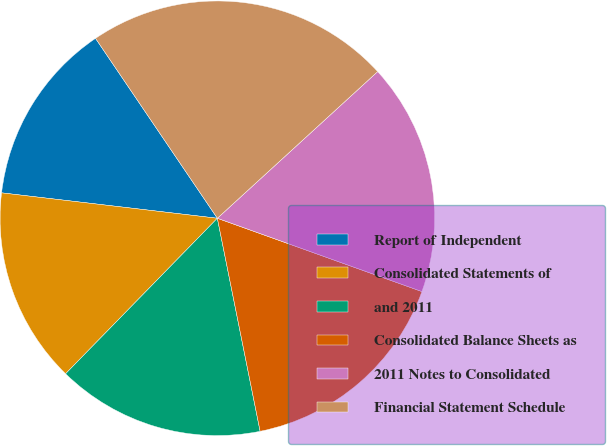Convert chart. <chart><loc_0><loc_0><loc_500><loc_500><pie_chart><fcel>Report of Independent<fcel>Consolidated Statements of<fcel>and 2011<fcel>Consolidated Balance Sheets as<fcel>2011 Notes to Consolidated<fcel>Financial Statement Schedule<nl><fcel>13.66%<fcel>14.56%<fcel>15.46%<fcel>16.37%<fcel>17.27%<fcel>22.68%<nl></chart> 